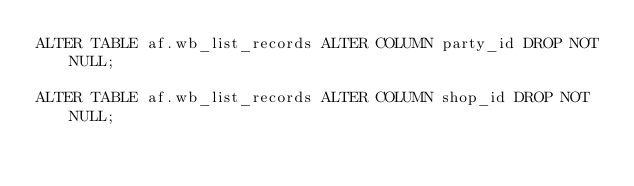Convert code to text. <code><loc_0><loc_0><loc_500><loc_500><_SQL_>ALTER TABLE af.wb_list_records ALTER COLUMN party_id DROP NOT NULL;

ALTER TABLE af.wb_list_records ALTER COLUMN shop_id DROP NOT NULL;
</code> 